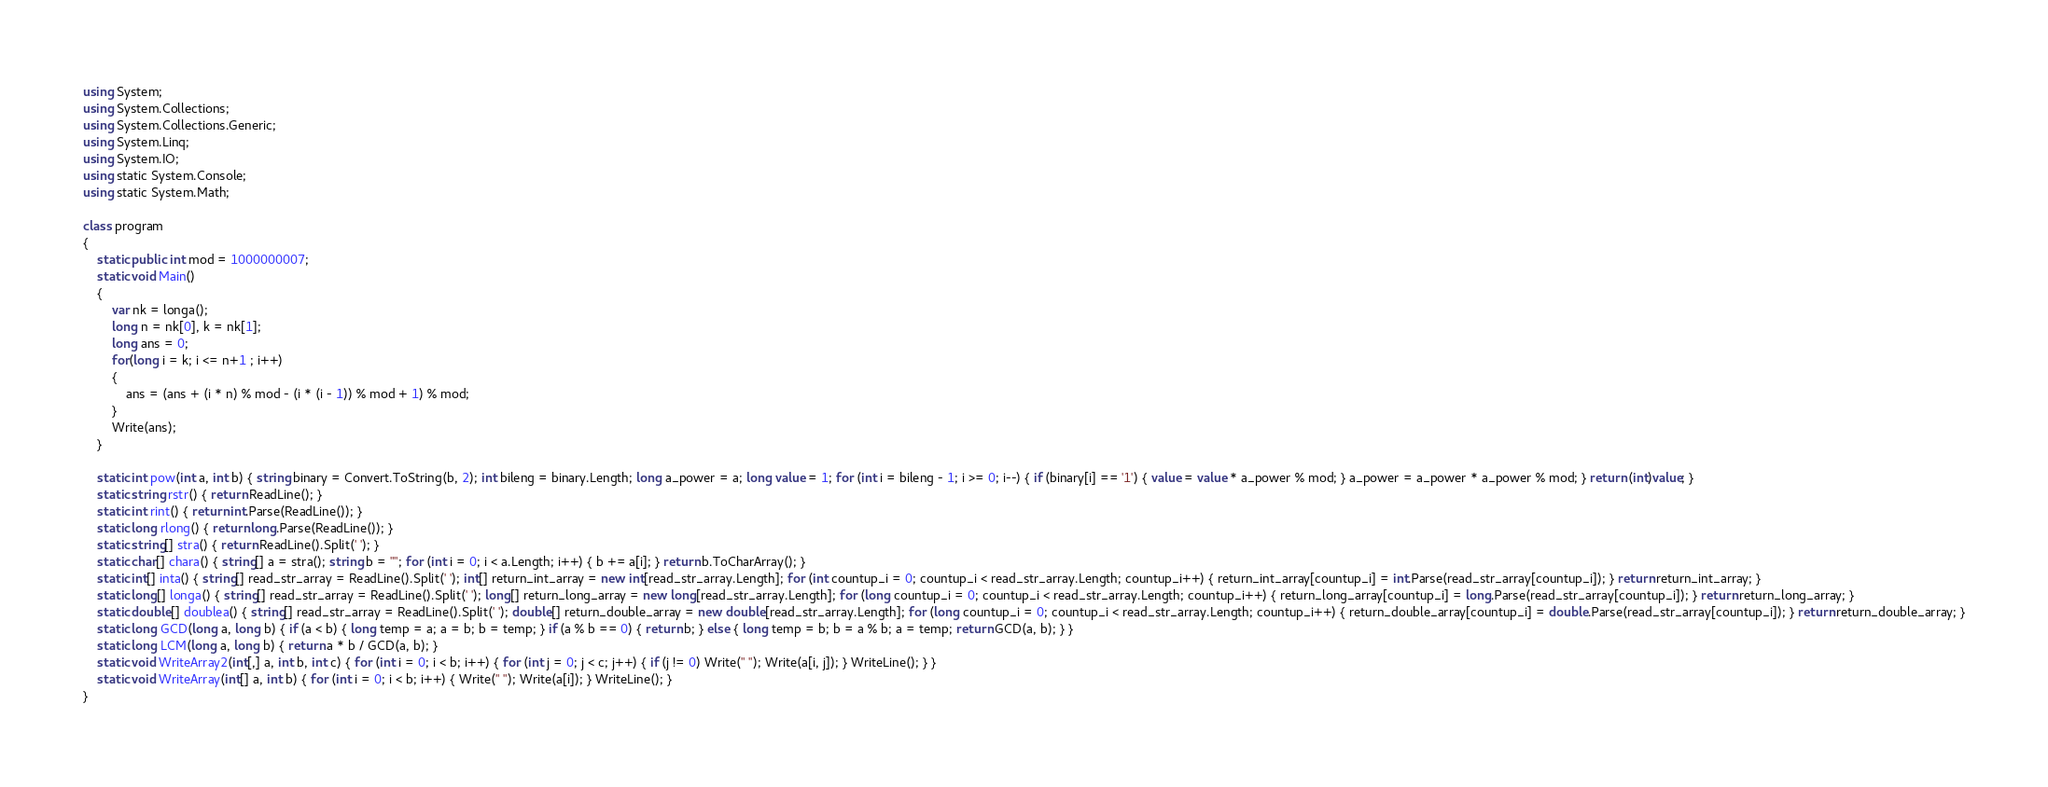Convert code to text. <code><loc_0><loc_0><loc_500><loc_500><_C#_>using System;
using System.Collections;
using System.Collections.Generic;
using System.Linq;
using System.IO;
using static System.Console;
using static System.Math;

class program
{
    static public int mod = 1000000007;
    static void Main()
    {
        var nk = longa();
        long n = nk[0], k = nk[1];
        long ans = 0;
        for(long i = k; i <= n+1 ; i++)
        {
            ans = (ans + (i * n) % mod - (i * (i - 1)) % mod + 1) % mod;
        }
        Write(ans);
    }

    static int pow(int a, int b) { string binary = Convert.ToString(b, 2); int bileng = binary.Length; long a_power = a; long value = 1; for (int i = bileng - 1; i >= 0; i--) { if (binary[i] == '1') { value = value * a_power % mod; } a_power = a_power * a_power % mod; } return (int)value; }
    static string rstr() { return ReadLine(); }
    static int rint() { return int.Parse(ReadLine()); }
    static long rlong() { return long.Parse(ReadLine()); }
    static string[] stra() { return ReadLine().Split(' '); }
    static char[] chara() { string[] a = stra(); string b = ""; for (int i = 0; i < a.Length; i++) { b += a[i]; } return b.ToCharArray(); }
    static int[] inta() { string[] read_str_array = ReadLine().Split(' '); int[] return_int_array = new int[read_str_array.Length]; for (int countup_i = 0; countup_i < read_str_array.Length; countup_i++) { return_int_array[countup_i] = int.Parse(read_str_array[countup_i]); } return return_int_array; }
    static long[] longa() { string[] read_str_array = ReadLine().Split(' '); long[] return_long_array = new long[read_str_array.Length]; for (long countup_i = 0; countup_i < read_str_array.Length; countup_i++) { return_long_array[countup_i] = long.Parse(read_str_array[countup_i]); } return return_long_array; }
    static double[] doublea() { string[] read_str_array = ReadLine().Split(' '); double[] return_double_array = new double[read_str_array.Length]; for (long countup_i = 0; countup_i < read_str_array.Length; countup_i++) { return_double_array[countup_i] = double.Parse(read_str_array[countup_i]); } return return_double_array; }
    static long GCD(long a, long b) { if (a < b) { long temp = a; a = b; b = temp; } if (a % b == 0) { return b; } else { long temp = b; b = a % b; a = temp; return GCD(a, b); } }
    static long LCM(long a, long b) { return a * b / GCD(a, b); }
    static void WriteArray2(int[,] a, int b, int c) { for (int i = 0; i < b; i++) { for (int j = 0; j < c; j++) { if (j != 0) Write(" "); Write(a[i, j]); } WriteLine(); } }
    static void WriteArray(int[] a, int b) { for (int i = 0; i < b; i++) { Write(" "); Write(a[i]); } WriteLine(); }
}
</code> 